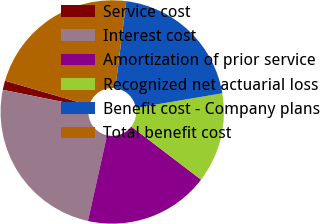Convert chart to OTSL. <chart><loc_0><loc_0><loc_500><loc_500><pie_chart><fcel>Service cost<fcel>Interest cost<fcel>Amortization of prior service<fcel>Recognized net actuarial loss<fcel>Benefit cost - Company plans<fcel>Total benefit cost<nl><fcel>1.33%<fcel>24.69%<fcel>18.13%<fcel>13.04%<fcel>20.31%<fcel>22.5%<nl></chart> 